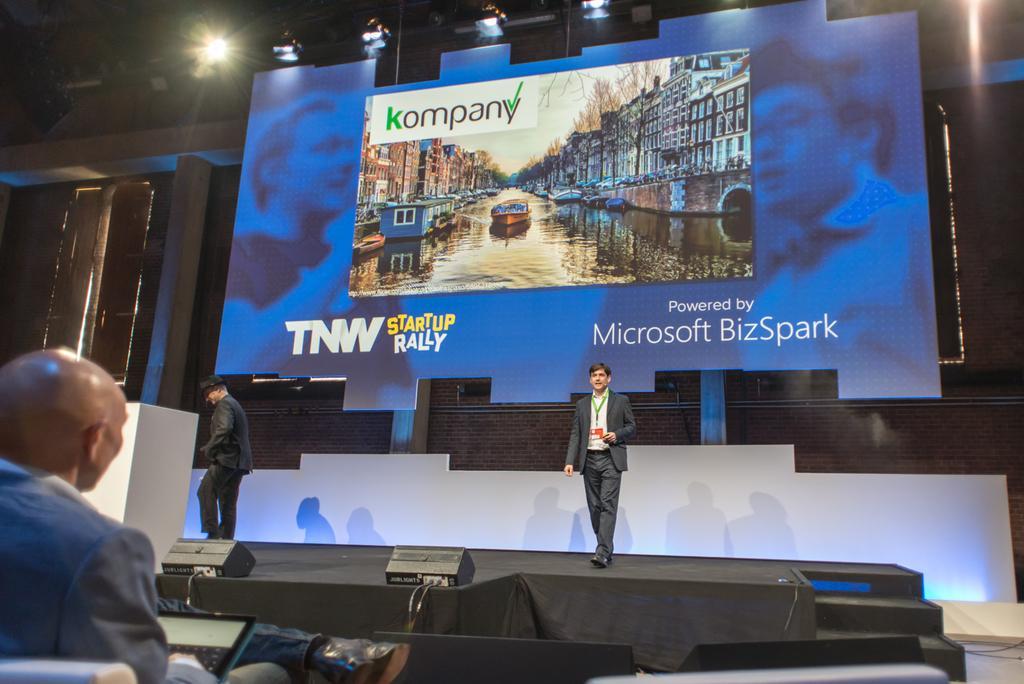Please provide a concise description of this image. In this image we can see two people standing on the stage, near that we can see a table, we can see written text on the board in the background, at the top we can see the lights, on the left we can see one person sitting. 